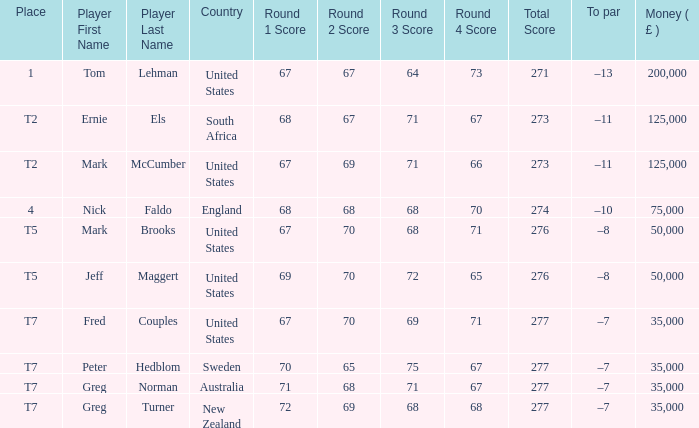What is the highest Money ( £ ), when Player is "Peter Hedblom"? 35000.0. 